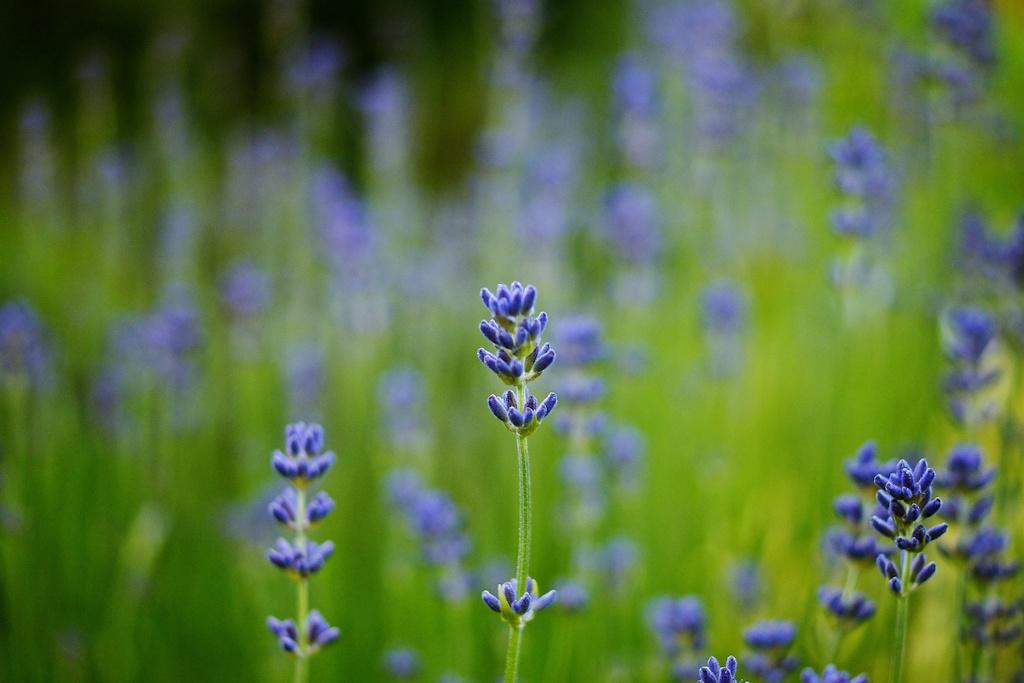What type of plants are visible in the image? There are plants with buds in the image. Can you describe the background of the image? The background of the image is blurred. What type of cheese is being used to hold the gate open in the image? There is no cheese or gate present in the image; it only features plants with buds and a blurred background. 